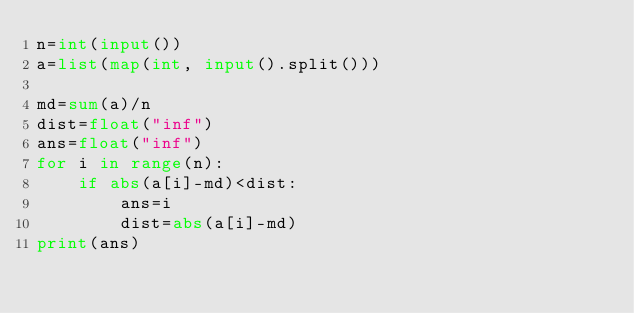<code> <loc_0><loc_0><loc_500><loc_500><_Python_>n=int(input())
a=list(map(int, input().split()))

md=sum(a)/n
dist=float("inf")
ans=float("inf")
for i in range(n):
    if abs(a[i]-md)<dist:
        ans=i
        dist=abs(a[i]-md)
print(ans)
</code> 